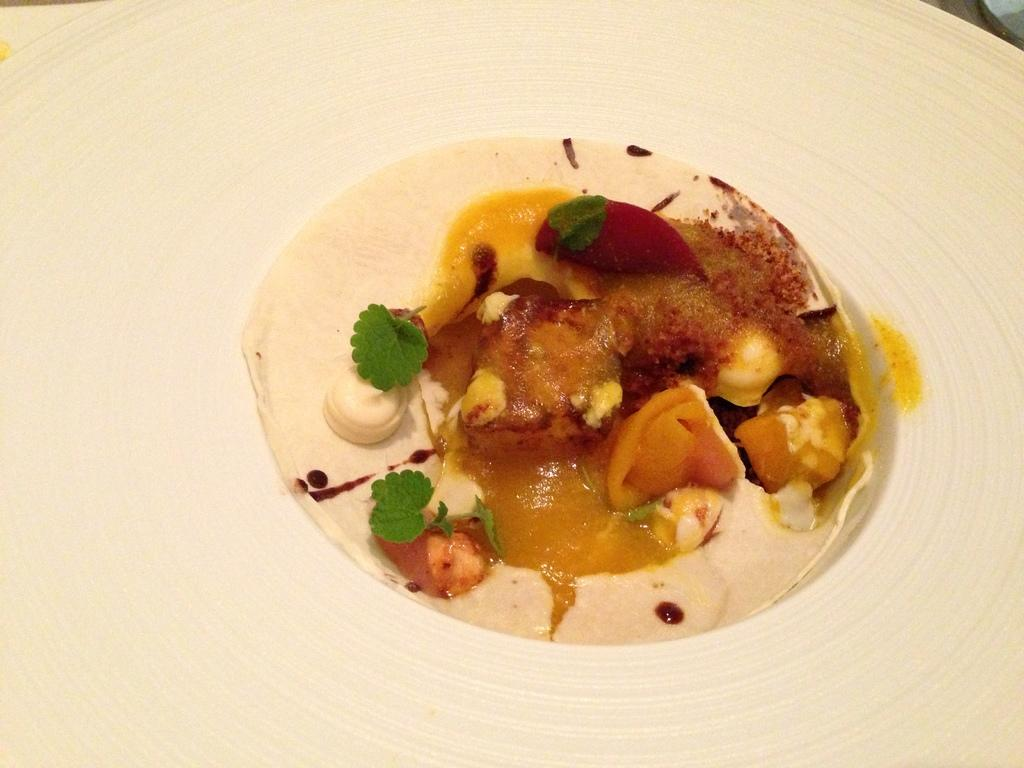What types of objects can be seen in the image? There are food items in the image. What is the color of the surface on which the food items are placed? The food items are placed on a white surface. Is there a squirrel wearing a shirt in the image? No, there is no squirrel or shirt present in the image. 